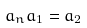<formula> <loc_0><loc_0><loc_500><loc_500>a _ { n } a _ { 1 } = a _ { 2 }</formula> 